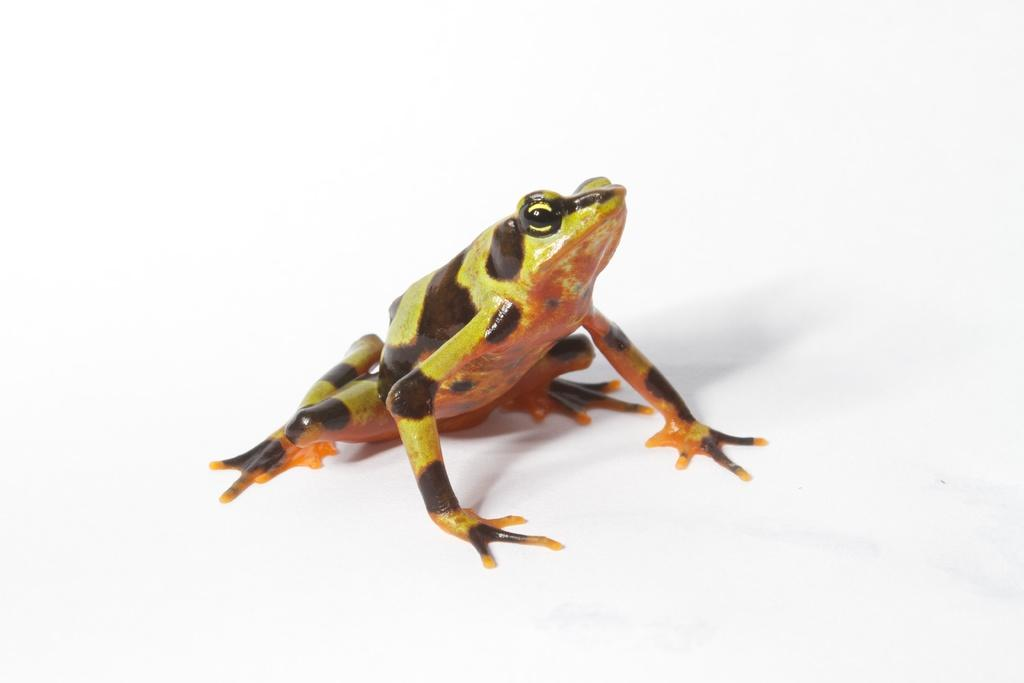What animal is present in the image? There is a frog in the image. What color is the background of the image? The background of the image appears to be white in color. What type of spy equipment can be seen in the image? There is no spy equipment present in the image; it features a frog against a white background. 